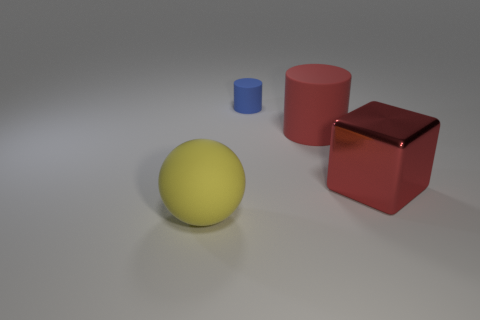Add 1 large yellow blocks. How many objects exist? 5 Subtract all spheres. How many objects are left? 3 Subtract all big red matte things. Subtract all brown blocks. How many objects are left? 3 Add 1 big red objects. How many big red objects are left? 3 Add 4 big rubber cylinders. How many big rubber cylinders exist? 5 Subtract 0 brown blocks. How many objects are left? 4 